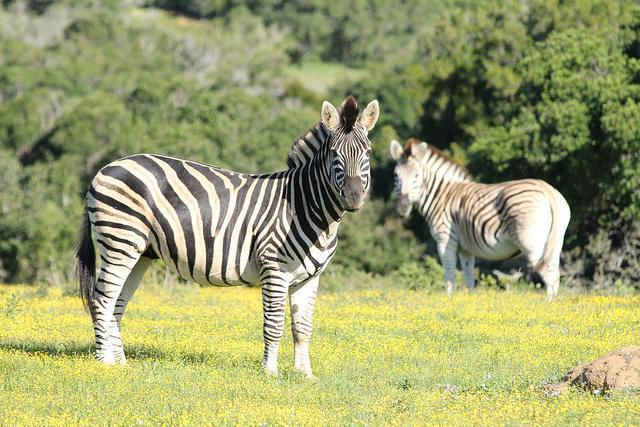How many zebras are visible?
Give a very brief answer. 2. How many zebras can be seen?
Give a very brief answer. 2. How many people are on skateboards?
Give a very brief answer. 0. 